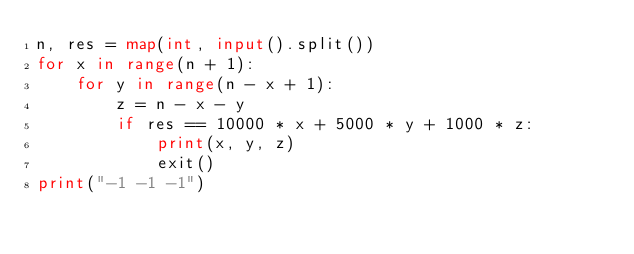<code> <loc_0><loc_0><loc_500><loc_500><_Python_>n, res = map(int, input().split())
for x in range(n + 1):
    for y in range(n - x + 1):
        z = n - x - y
        if res == 10000 * x + 5000 * y + 1000 * z:
            print(x, y, z)
            exit()
print("-1 -1 -1")</code> 